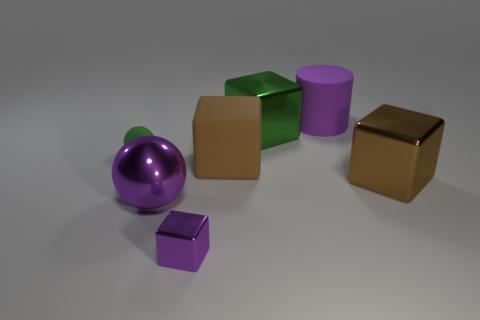Subtract all large green blocks. How many blocks are left? 3 Subtract all yellow cylinders. How many brown cubes are left? 2 Add 2 purple things. How many objects exist? 9 Subtract all green cubes. How many cubes are left? 3 Subtract 2 brown cubes. How many objects are left? 5 Subtract all balls. How many objects are left? 5 Subtract 3 blocks. How many blocks are left? 1 Subtract all red blocks. Subtract all brown spheres. How many blocks are left? 4 Subtract all large purple metallic spheres. Subtract all green blocks. How many objects are left? 5 Add 7 brown metal objects. How many brown metal objects are left? 8 